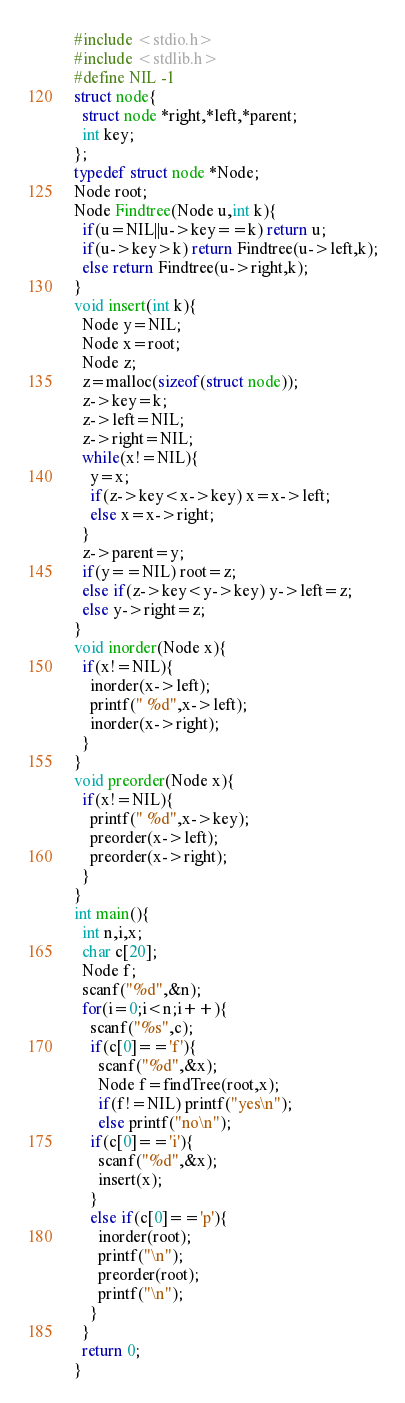Convert code to text. <code><loc_0><loc_0><loc_500><loc_500><_C_>#include <stdio.h>
#include <stdlib.h>
#define NIL -1
struct node{
  struct node *right,*left,*parent;
  int key;
};
typedef struct node *Node;
Node root;
Node Findtree(Node u,int k){
  if(u=NIL||u->key==k) return u;
  if(u->key>k) return Findtree(u->left,k);
  else return Findtree(u->right,k);
}
void insert(int k){
  Node y=NIL;
  Node x=root;
  Node z;
  z=malloc(sizeof(struct node));
  z->key=k;
  z->left=NIL;
  z->right=NIL;
  while(x!=NIL){
    y=x;
    if(z->key<x->key) x=x->left;
    else x=x->right;
  }
  z->parent=y;
  if(y==NIL) root=z;
  else if(z->key<y->key) y->left=z;
  else y->right=z;
}
void inorder(Node x){
  if(x!=NIL){
    inorder(x->left);
    printf(" %d",x->left);
    inorder(x->right);
  }
}
void preorder(Node x){
  if(x!=NIL){
    printf(" %d",x->key);
    preorder(x->left);
    preorder(x->right);
  }
}
int main(){
  int n,i,x;
  char c[20];
  Node f;
  scanf("%d",&n);
  for(i=0;i<n;i++){
    scanf("%s",c);
    if(c[0]=='f'){
      scanf("%d",&x);
      Node f=findTree(root,x);
      if(f!=NIL) printf("yes\n");
      else printf("no\n");
    if(c[0]=='i'){
      scanf("%d",&x);
      insert(x);
    }
    else if(c[0]=='p'){
      inorder(root);
      printf("\n");
      preorder(root);
      printf("\n");
    }
  }
  return 0;
}  </code> 